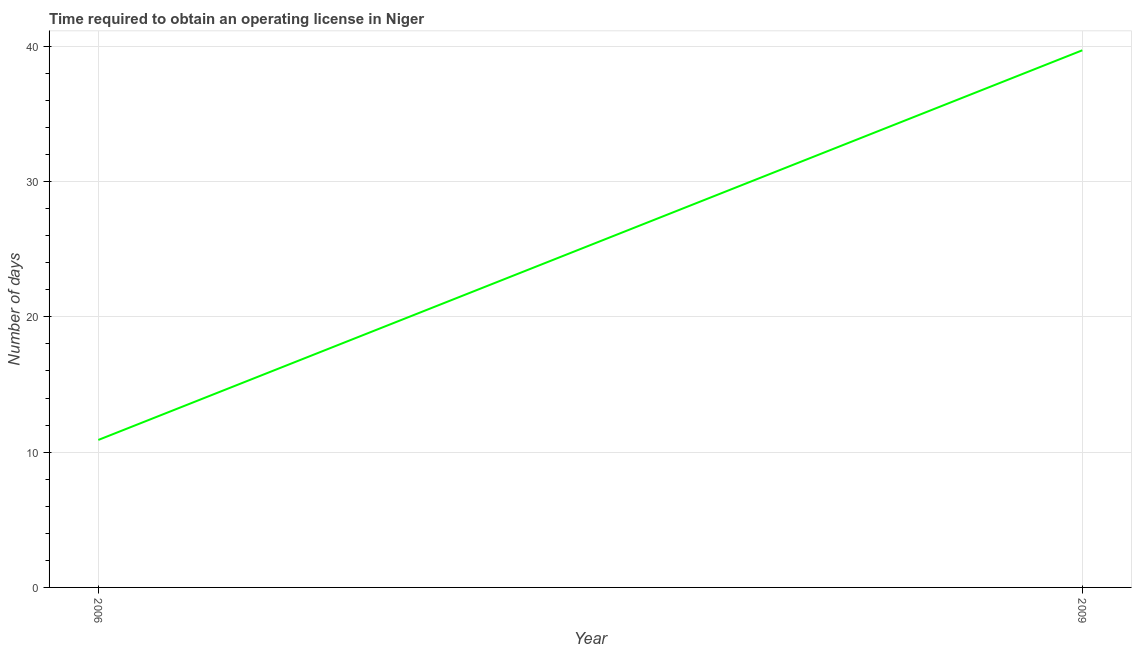What is the number of days to obtain operating license in 2009?
Provide a short and direct response. 39.7. Across all years, what is the maximum number of days to obtain operating license?
Your answer should be compact. 39.7. In which year was the number of days to obtain operating license minimum?
Keep it short and to the point. 2006. What is the sum of the number of days to obtain operating license?
Provide a succinct answer. 50.6. What is the difference between the number of days to obtain operating license in 2006 and 2009?
Keep it short and to the point. -28.8. What is the average number of days to obtain operating license per year?
Your answer should be compact. 25.3. What is the median number of days to obtain operating license?
Provide a succinct answer. 25.3. In how many years, is the number of days to obtain operating license greater than 8 days?
Your response must be concise. 2. Do a majority of the years between 2009 and 2006 (inclusive) have number of days to obtain operating license greater than 16 days?
Offer a very short reply. No. What is the ratio of the number of days to obtain operating license in 2006 to that in 2009?
Keep it short and to the point. 0.27. Is the number of days to obtain operating license in 2006 less than that in 2009?
Make the answer very short. Yes. In how many years, is the number of days to obtain operating license greater than the average number of days to obtain operating license taken over all years?
Provide a succinct answer. 1. Does the number of days to obtain operating license monotonically increase over the years?
Offer a very short reply. Yes. How many lines are there?
Offer a terse response. 1. How many years are there in the graph?
Offer a terse response. 2. What is the difference between two consecutive major ticks on the Y-axis?
Keep it short and to the point. 10. Does the graph contain any zero values?
Offer a terse response. No. What is the title of the graph?
Ensure brevity in your answer.  Time required to obtain an operating license in Niger. What is the label or title of the Y-axis?
Offer a very short reply. Number of days. What is the Number of days of 2009?
Give a very brief answer. 39.7. What is the difference between the Number of days in 2006 and 2009?
Offer a very short reply. -28.8. What is the ratio of the Number of days in 2006 to that in 2009?
Make the answer very short. 0.28. 